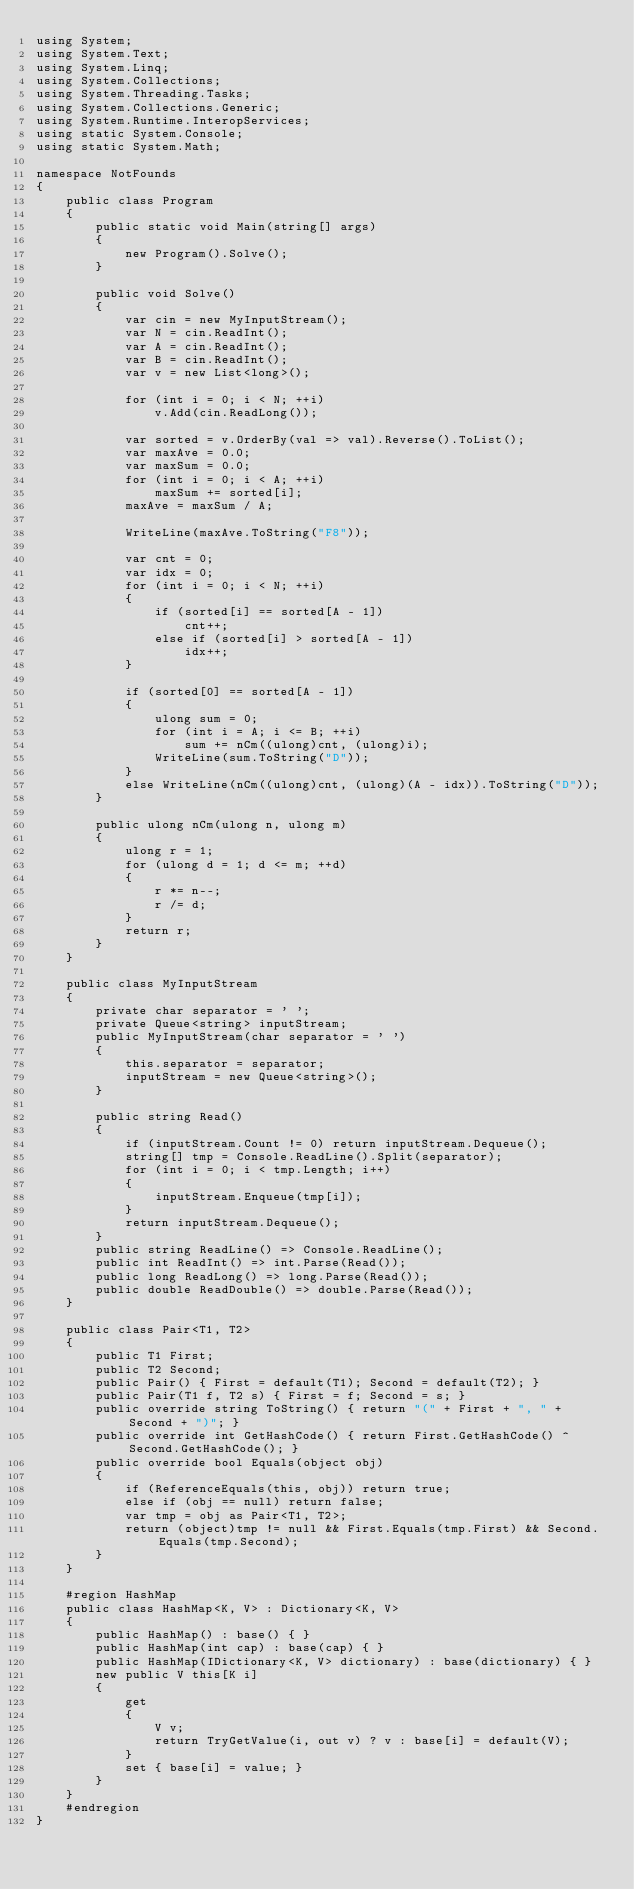Convert code to text. <code><loc_0><loc_0><loc_500><loc_500><_C#_>using System;
using System.Text;
using System.Linq;
using System.Collections;
using System.Threading.Tasks;
using System.Collections.Generic;
using System.Runtime.InteropServices;
using static System.Console;
using static System.Math;

namespace NotFounds
{
    public class Program
    {
        public static void Main(string[] args)
        {
            new Program().Solve();
        }

        public void Solve()
        {
            var cin = new MyInputStream();
            var N = cin.ReadInt();
            var A = cin.ReadInt();
            var B = cin.ReadInt();
            var v = new List<long>();

            for (int i = 0; i < N; ++i)
                v.Add(cin.ReadLong());

            var sorted = v.OrderBy(val => val).Reverse().ToList();
            var maxAve = 0.0;
            var maxSum = 0.0;
            for (int i = 0; i < A; ++i)
                maxSum += sorted[i];
            maxAve = maxSum / A;

            WriteLine(maxAve.ToString("F8"));

            var cnt = 0;
            var idx = 0;
            for (int i = 0; i < N; ++i)
            {
                if (sorted[i] == sorted[A - 1])
                    cnt++;
                else if (sorted[i] > sorted[A - 1])
                    idx++;
            }

            if (sorted[0] == sorted[A - 1])
            {
                ulong sum = 0;
                for (int i = A; i <= B; ++i)
                    sum += nCm((ulong)cnt, (ulong)i);
                WriteLine(sum.ToString("D"));
            }
            else WriteLine(nCm((ulong)cnt, (ulong)(A - idx)).ToString("D"));
        }

        public ulong nCm(ulong n, ulong m)
        {
            ulong r = 1;
            for (ulong d = 1; d <= m; ++d)
            {
                r *= n--;
                r /= d;
            }
            return r;
        }
    }

    public class MyInputStream
    {
        private char separator = ' ';
        private Queue<string> inputStream;
        public MyInputStream(char separator = ' ')
        {
            this.separator = separator;
            inputStream = new Queue<string>();
        }

        public string Read()
        {
            if (inputStream.Count != 0) return inputStream.Dequeue();
            string[] tmp = Console.ReadLine().Split(separator);
            for (int i = 0; i < tmp.Length; i++)
            {
                inputStream.Enqueue(tmp[i]);
            }
            return inputStream.Dequeue();
        }
        public string ReadLine() => Console.ReadLine();
        public int ReadInt() => int.Parse(Read());
        public long ReadLong() => long.Parse(Read());
        public double ReadDouble() => double.Parse(Read());
    }

    public class Pair<T1, T2>
    {
        public T1 First;
        public T2 Second;
        public Pair() { First = default(T1); Second = default(T2); }
        public Pair(T1 f, T2 s) { First = f; Second = s; }
        public override string ToString() { return "(" + First + ", " + Second + ")"; }
        public override int GetHashCode() { return First.GetHashCode() ^ Second.GetHashCode(); }
        public override bool Equals(object obj)
        {
            if (ReferenceEquals(this, obj)) return true;
            else if (obj == null) return false;
            var tmp = obj as Pair<T1, T2>;
            return (object)tmp != null && First.Equals(tmp.First) && Second.Equals(tmp.Second);
        }
    }

    #region HashMap
    public class HashMap<K, V> : Dictionary<K, V>
    {
        public HashMap() : base() { }
        public HashMap(int cap) : base(cap) { }
        public HashMap(IDictionary<K, V> dictionary) : base(dictionary) { }
        new public V this[K i]
        {
            get
            {
                V v;
                return TryGetValue(i, out v) ? v : base[i] = default(V);
            }
            set { base[i] = value; }
        }
    }
    #endregion
}
</code> 